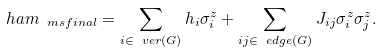Convert formula to latex. <formula><loc_0><loc_0><loc_500><loc_500>\ h a m _ { \ m s { f i n a l } } = \sum _ { i \in \ v e r ( G ) } h _ { i } \sigma ^ { z } _ { i } + \sum _ { i j \in \ e d g e ( G ) } J _ { i j } \sigma ^ { z } _ { i } \sigma ^ { z } _ { j } .</formula> 